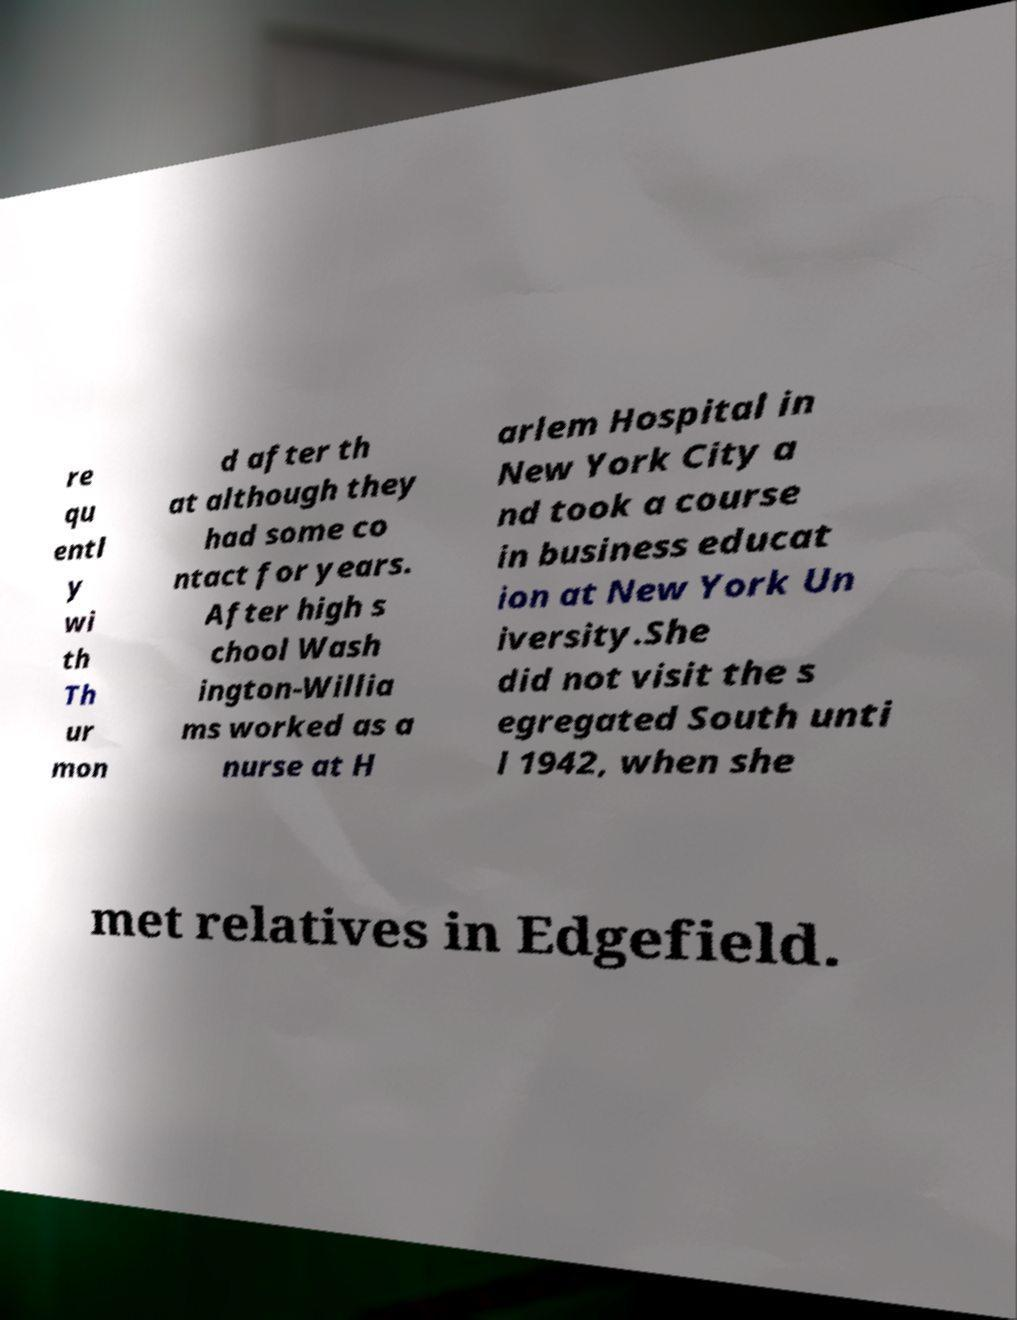Could you assist in decoding the text presented in this image and type it out clearly? re qu entl y wi th Th ur mon d after th at although they had some co ntact for years. After high s chool Wash ington-Willia ms worked as a nurse at H arlem Hospital in New York City a nd took a course in business educat ion at New York Un iversity.She did not visit the s egregated South unti l 1942, when she met relatives in Edgefield. 